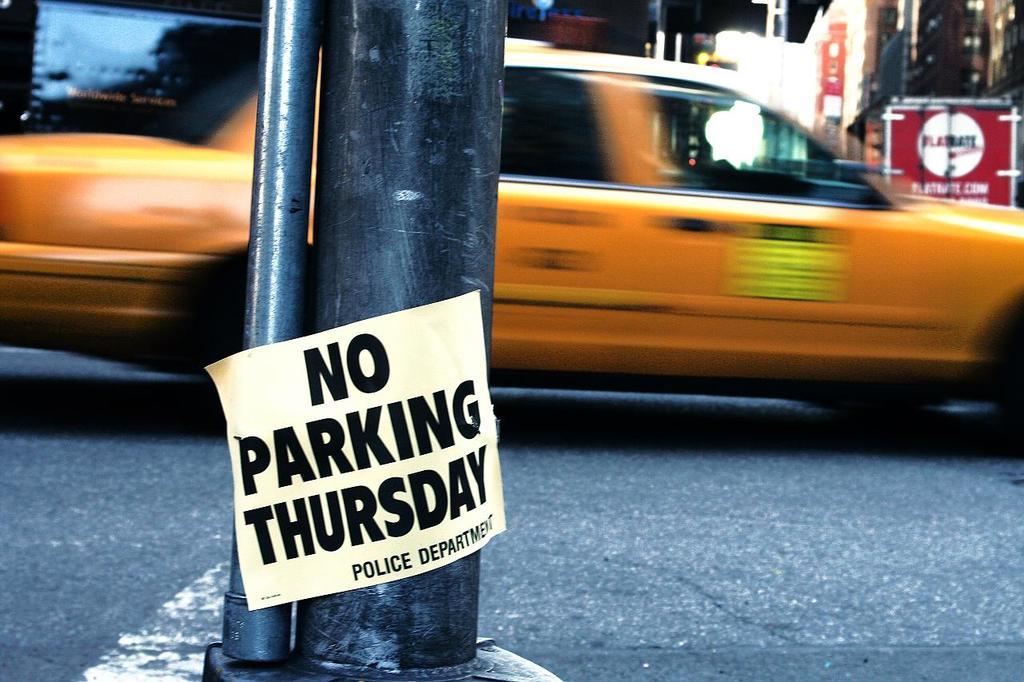When is parking not allowed?
Your answer should be compact. Thursday. Who is the sign from?
Your answer should be compact. Police department. 